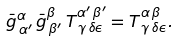<formula> <loc_0><loc_0><loc_500><loc_500>\bar { g } ^ { \alpha } _ { \, \alpha ^ { \prime } } \, \bar { g } ^ { \beta } _ { \, \beta ^ { \prime } } \, T ^ { \alpha ^ { \prime } \, \beta ^ { \prime } } _ { \, \gamma \, \delta \epsilon } = T ^ { \alpha \, \beta } _ { \, \gamma \, \delta \epsilon } .</formula> 